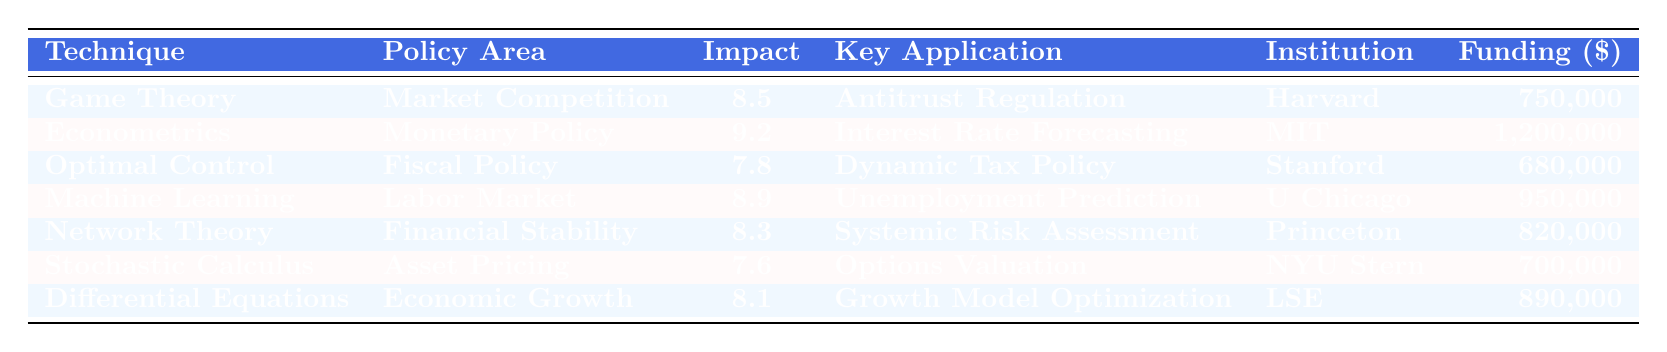What is the Impact Score of Econometrics? The Impact Score of Econometrics is stated directly in the table as 9.2.
Answer: 9.2 Which technique has the highest Impact Score? By comparing all the Impact Scores listed, Econometrics has the highest score of 9.2.
Answer: Econometrics How much funding was allocated for the Game Theory study? The table specifies that the funding amount for the Game Theory study is 750,000.
Answer: 750,000 What was the Year of Study for Machine Learning? The Year of Study for Machine Learning is indicated in the table as 2021.
Answer: 2021 Which research institution conducted the study on Differential Equations? The table shows that the London School of Economics (LSE) conducted the study on Differential Equations.
Answer: London School of Economics What is the average Impact Score of the techniques in the table? The Impact Scores are 8.5, 9.2, 7.8, 8.9, 8.3, 7.6, and 8.1. Adding these scores gives 59.4, and there are 7 techniques. The average is 59.4 / 7 = 8.486.
Answer: 8.486 Is the funding for Optimal Control Theory higher than the funding for Stochastic Calculus? The funding for Optimal Control Theory is 680,000, and for Stochastic Calculus, it is 700,000. Since 680,000 is less than 700,000, the statement is false.
Answer: No How many research institutions conducted studies in 2020? The table lists Econometrics and Network Theory both being studied in 2020, making it a total of 2 institutions.
Answer: 2 Which technique had a lower Impact Score: Machine Learning or Differential Equations? The Impact Score for Machine Learning is 8.9, and for Differential Equations, it is 8.1. Since 8.1 is lower than 8.9, Differential Equations had the lower score.
Answer: Differential Equations What is the difference in funding between the highest and lowest funded studies? The highest funding is 1,200,000 (Econometrics), and the lowest is 680,000 (Optimal Control Theory). The difference is 1,200,000 - 680,000 = 520,000.
Answer: 520,000 